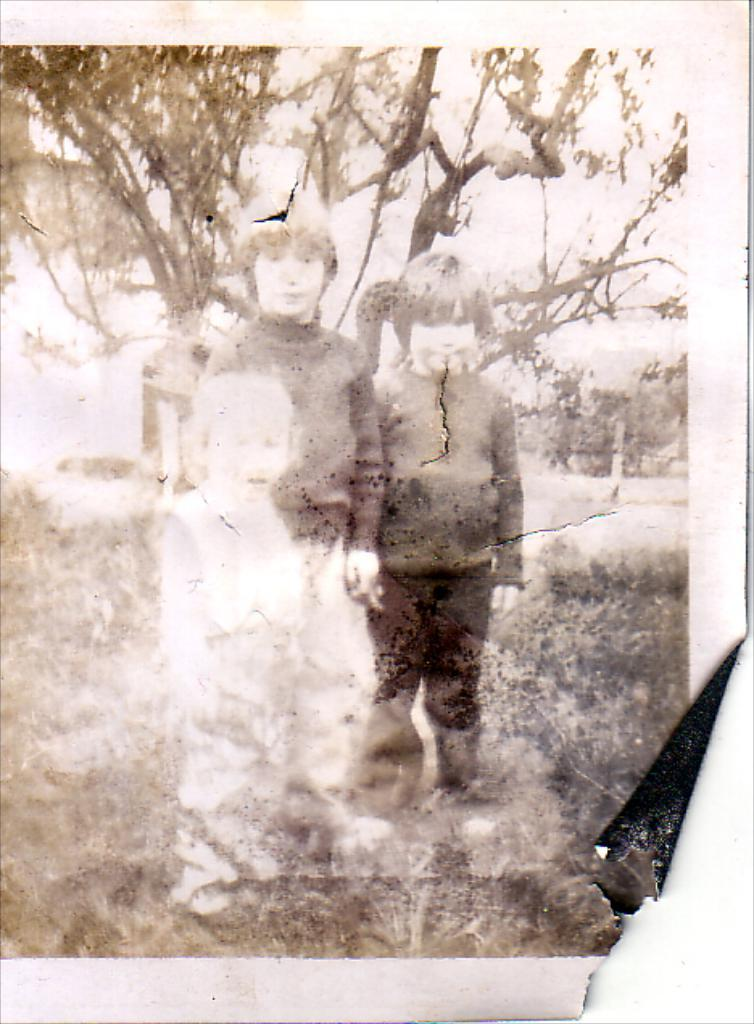What is the main subject of the image? There is a photograph in the image. How many kids are in the photograph? There are three kids standing in the photograph. What else can be seen in the image besides the photograph? There are plants visible in the image. What is visible in the background of the image? There are trees in the background of the image. What degree does the steam have in the image? There is no steam present in the image. What statement can be made about the kids' clothing in the photograph? The provided facts do not mention the kids' clothing, so we cannot make a statement about it. 